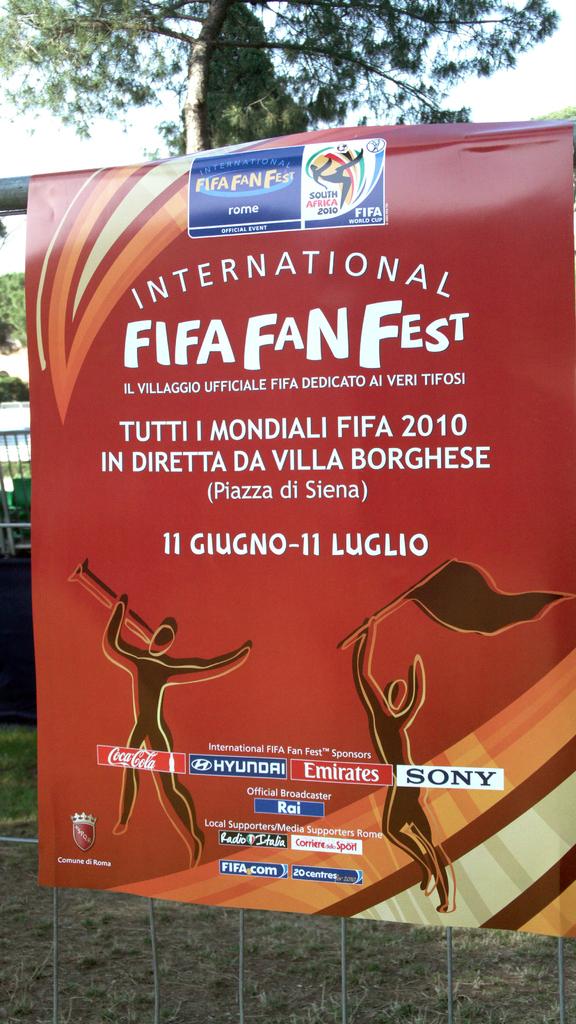What is this?
Offer a terse response. Fifa fan fest. Who is the brand on the poster?
Keep it short and to the point. Fifa fan fest. 